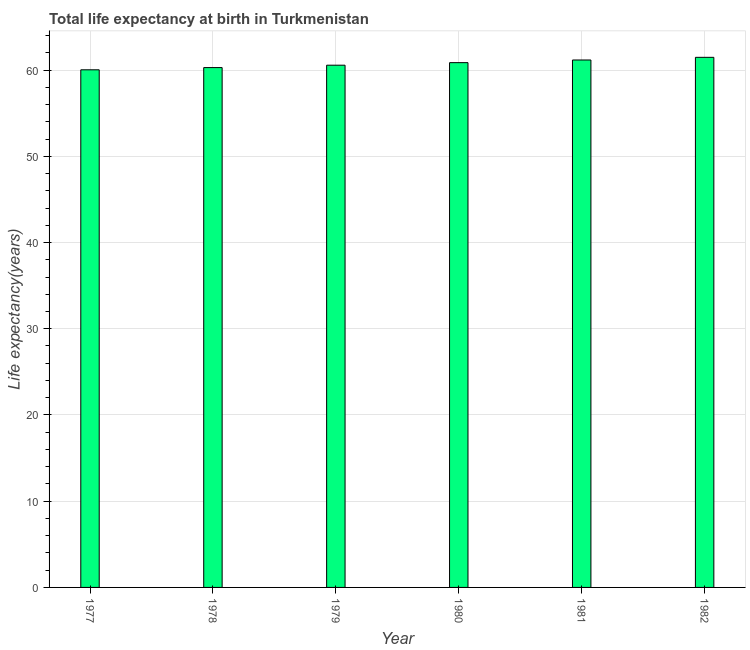What is the title of the graph?
Ensure brevity in your answer.  Total life expectancy at birth in Turkmenistan. What is the label or title of the X-axis?
Provide a short and direct response. Year. What is the label or title of the Y-axis?
Provide a succinct answer. Life expectancy(years). What is the life expectancy at birth in 1980?
Provide a short and direct response. 60.86. Across all years, what is the maximum life expectancy at birth?
Your answer should be very brief. 61.48. Across all years, what is the minimum life expectancy at birth?
Your response must be concise. 60.03. In which year was the life expectancy at birth maximum?
Your answer should be very brief. 1982. In which year was the life expectancy at birth minimum?
Ensure brevity in your answer.  1977. What is the sum of the life expectancy at birth?
Offer a terse response. 364.39. What is the difference between the life expectancy at birth in 1978 and 1982?
Keep it short and to the point. -1.19. What is the average life expectancy at birth per year?
Your response must be concise. 60.73. What is the median life expectancy at birth?
Provide a short and direct response. 60.71. Do a majority of the years between 1980 and 1979 (inclusive) have life expectancy at birth greater than 2 years?
Your answer should be compact. No. Is the difference between the life expectancy at birth in 1977 and 1981 greater than the difference between any two years?
Ensure brevity in your answer.  No. What is the difference between the highest and the second highest life expectancy at birth?
Make the answer very short. 0.31. What is the difference between the highest and the lowest life expectancy at birth?
Offer a very short reply. 1.45. In how many years, is the life expectancy at birth greater than the average life expectancy at birth taken over all years?
Give a very brief answer. 3. Are all the bars in the graph horizontal?
Offer a terse response. No. What is the difference between two consecutive major ticks on the Y-axis?
Your answer should be compact. 10. What is the Life expectancy(years) in 1977?
Your response must be concise. 60.03. What is the Life expectancy(years) of 1978?
Provide a short and direct response. 60.29. What is the Life expectancy(years) in 1979?
Ensure brevity in your answer.  60.57. What is the Life expectancy(years) of 1980?
Keep it short and to the point. 60.86. What is the Life expectancy(years) of 1981?
Offer a very short reply. 61.17. What is the Life expectancy(years) of 1982?
Offer a very short reply. 61.48. What is the difference between the Life expectancy(years) in 1977 and 1978?
Make the answer very short. -0.26. What is the difference between the Life expectancy(years) in 1977 and 1979?
Your answer should be compact. -0.53. What is the difference between the Life expectancy(years) in 1977 and 1980?
Offer a terse response. -0.83. What is the difference between the Life expectancy(years) in 1977 and 1981?
Give a very brief answer. -1.14. What is the difference between the Life expectancy(years) in 1977 and 1982?
Offer a very short reply. -1.45. What is the difference between the Life expectancy(years) in 1978 and 1979?
Your answer should be compact. -0.28. What is the difference between the Life expectancy(years) in 1978 and 1980?
Your answer should be very brief. -0.57. What is the difference between the Life expectancy(years) in 1978 and 1981?
Provide a short and direct response. -0.88. What is the difference between the Life expectancy(years) in 1978 and 1982?
Make the answer very short. -1.19. What is the difference between the Life expectancy(years) in 1979 and 1980?
Give a very brief answer. -0.3. What is the difference between the Life expectancy(years) in 1979 and 1981?
Your answer should be very brief. -0.6. What is the difference between the Life expectancy(years) in 1979 and 1982?
Keep it short and to the point. -0.91. What is the difference between the Life expectancy(years) in 1980 and 1981?
Provide a short and direct response. -0.31. What is the difference between the Life expectancy(years) in 1980 and 1982?
Your answer should be very brief. -0.62. What is the difference between the Life expectancy(years) in 1981 and 1982?
Provide a short and direct response. -0.31. What is the ratio of the Life expectancy(years) in 1977 to that in 1979?
Your answer should be compact. 0.99. What is the ratio of the Life expectancy(years) in 1977 to that in 1980?
Your answer should be very brief. 0.99. What is the ratio of the Life expectancy(years) in 1979 to that in 1980?
Offer a very short reply. 0.99. What is the ratio of the Life expectancy(years) in 1979 to that in 1981?
Make the answer very short. 0.99. What is the ratio of the Life expectancy(years) in 1980 to that in 1981?
Make the answer very short. 0.99. What is the ratio of the Life expectancy(years) in 1980 to that in 1982?
Ensure brevity in your answer.  0.99. 